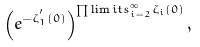Convert formula to latex. <formula><loc_0><loc_0><loc_500><loc_500>\left ( e ^ { - \zeta _ { 1 } ^ { ^ { \prime } } ( 0 ) } \right ) ^ { \prod \lim i t s _ { i = 2 } ^ { \infty } \zeta _ { i } ( 0 ) } ,</formula> 